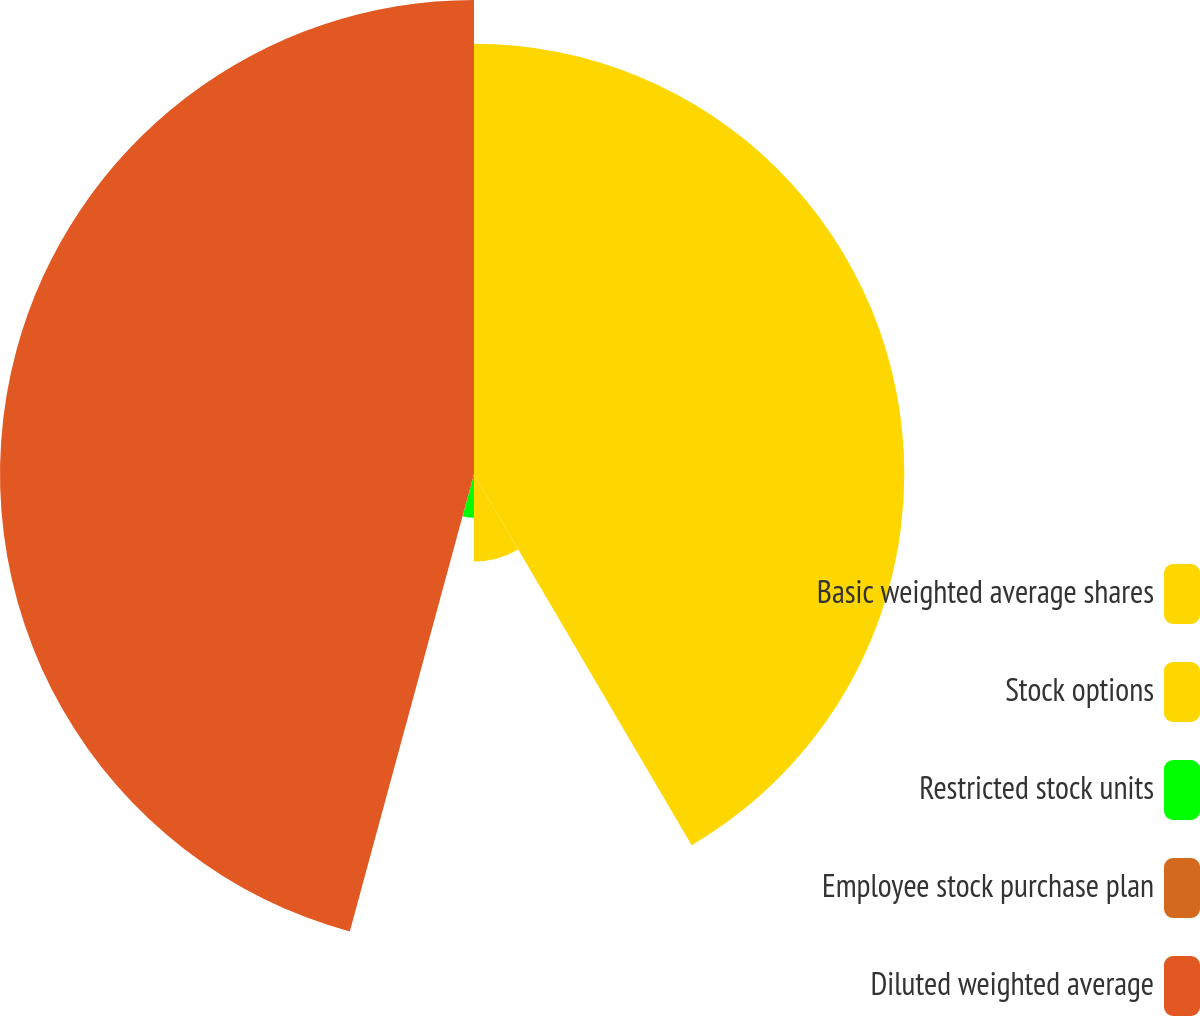<chart> <loc_0><loc_0><loc_500><loc_500><pie_chart><fcel>Basic weighted average shares<fcel>Stock options<fcel>Restricted stock units<fcel>Employee stock purchase plan<fcel>Diluted weighted average<nl><fcel>41.56%<fcel>8.44%<fcel>4.22%<fcel>0.0%<fcel>45.78%<nl></chart> 